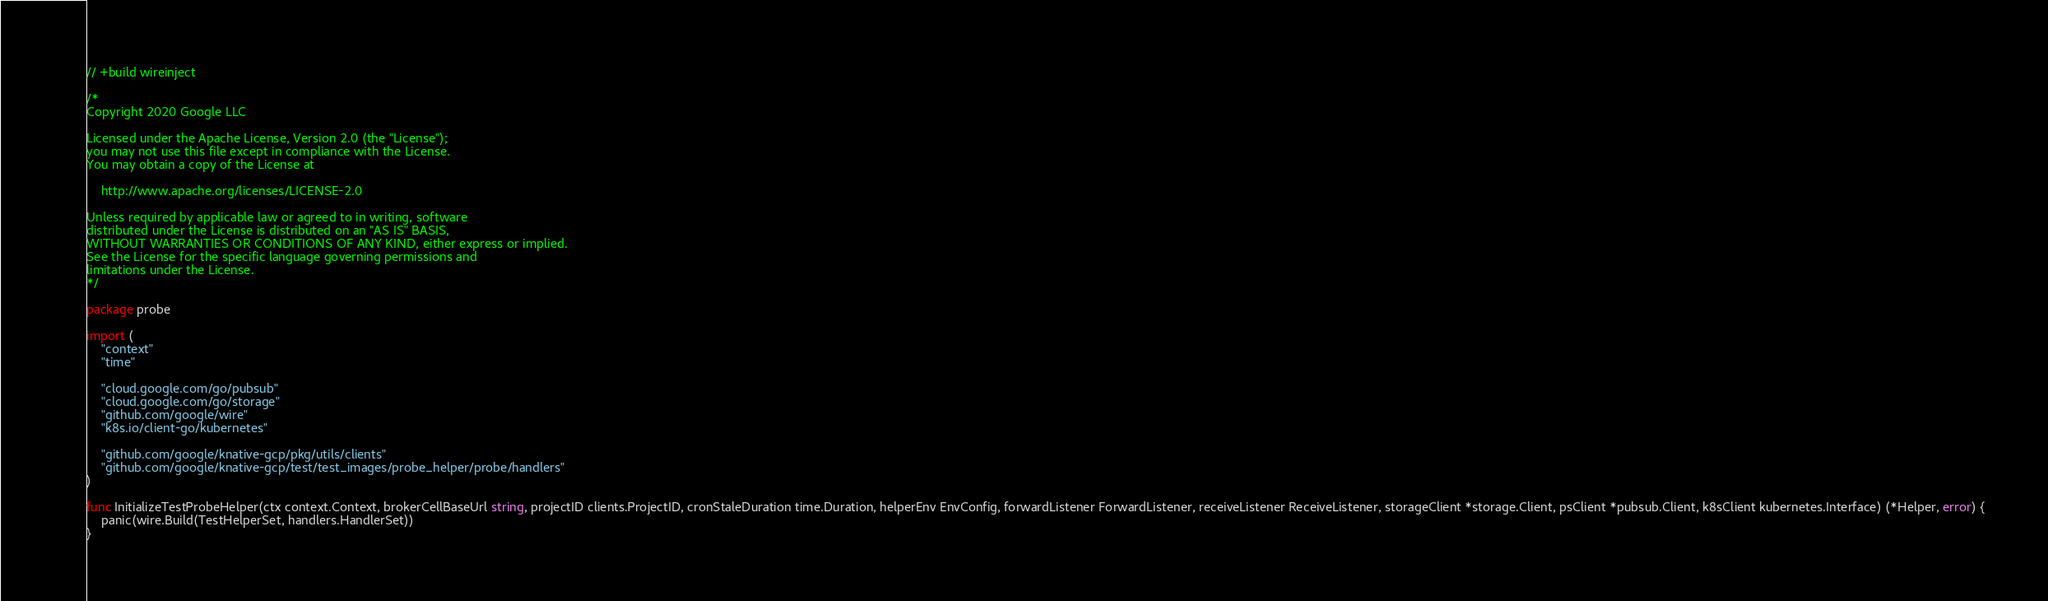<code> <loc_0><loc_0><loc_500><loc_500><_Go_>// +build wireinject

/*
Copyright 2020 Google LLC

Licensed under the Apache License, Version 2.0 (the "License");
you may not use this file except in compliance with the License.
You may obtain a copy of the License at

    http://www.apache.org/licenses/LICENSE-2.0

Unless required by applicable law or agreed to in writing, software
distributed under the License is distributed on an "AS IS" BASIS,
WITHOUT WARRANTIES OR CONDITIONS OF ANY KIND, either express or implied.
See the License for the specific language governing permissions and
limitations under the License.
*/

package probe

import (
	"context"
	"time"

	"cloud.google.com/go/pubsub"
	"cloud.google.com/go/storage"
	"github.com/google/wire"
	"k8s.io/client-go/kubernetes"

	"github.com/google/knative-gcp/pkg/utils/clients"
	"github.com/google/knative-gcp/test/test_images/probe_helper/probe/handlers"
)

func InitializeTestProbeHelper(ctx context.Context, brokerCellBaseUrl string, projectID clients.ProjectID, cronStaleDuration time.Duration, helperEnv EnvConfig, forwardListener ForwardListener, receiveListener ReceiveListener, storageClient *storage.Client, psClient *pubsub.Client, k8sClient kubernetes.Interface) (*Helper, error) {
	panic(wire.Build(TestHelperSet, handlers.HandlerSet))
}
</code> 